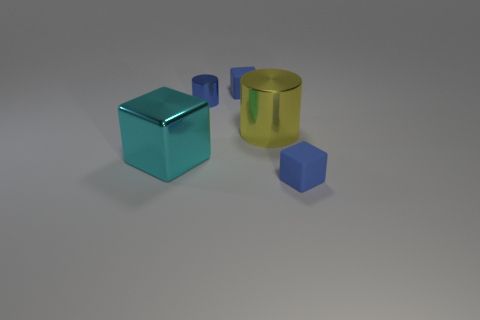How many small cubes are in front of the yellow cylinder and behind the small metal object?
Ensure brevity in your answer.  0. Is the number of big cyan metal objects greater than the number of big red shiny balls?
Offer a terse response. Yes. How many other objects are there of the same shape as the cyan object?
Your response must be concise. 2. What is the object that is in front of the large yellow object and on the right side of the large cyan metallic cube made of?
Provide a succinct answer. Rubber. What size is the cyan block?
Your response must be concise. Large. There is a blue matte block that is behind the tiny blue matte cube that is in front of the shiny cube; how many objects are in front of it?
Your response must be concise. 4. There is a big object on the right side of the big cyan metal cube to the left of the large yellow cylinder; what is its shape?
Your answer should be very brief. Cylinder. There is a yellow thing that is the same shape as the tiny blue metal object; what is its size?
Keep it short and to the point. Large. There is a tiny cube in front of the yellow metal cylinder; what is its color?
Your answer should be compact. Blue. What is the material of the thing that is to the left of the blue thing that is left of the small blue matte cube that is behind the large yellow metallic thing?
Offer a very short reply. Metal. 